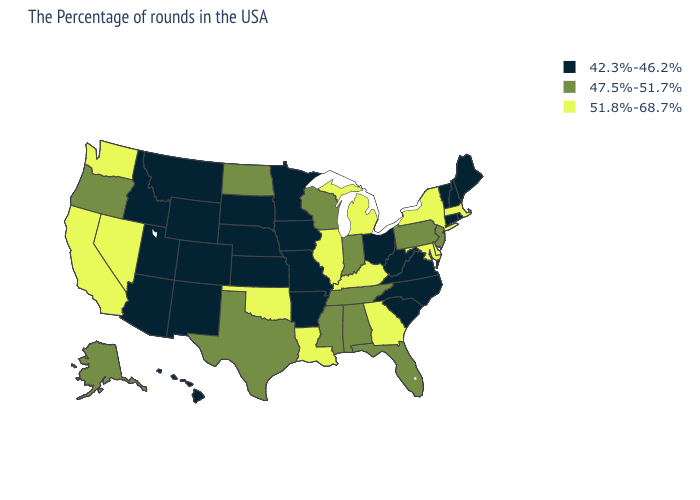Name the states that have a value in the range 47.5%-51.7%?
Keep it brief. New Jersey, Pennsylvania, Florida, Indiana, Alabama, Tennessee, Wisconsin, Mississippi, Texas, North Dakota, Oregon, Alaska. Does the map have missing data?
Keep it brief. No. Is the legend a continuous bar?
Quick response, please. No. Does Maryland have the same value as Washington?
Be succinct. Yes. Is the legend a continuous bar?
Quick response, please. No. What is the value of Delaware?
Quick response, please. 51.8%-68.7%. Name the states that have a value in the range 47.5%-51.7%?
Concise answer only. New Jersey, Pennsylvania, Florida, Indiana, Alabama, Tennessee, Wisconsin, Mississippi, Texas, North Dakota, Oregon, Alaska. Which states have the highest value in the USA?
Quick response, please. Massachusetts, New York, Delaware, Maryland, Georgia, Michigan, Kentucky, Illinois, Louisiana, Oklahoma, Nevada, California, Washington. What is the highest value in the Northeast ?
Give a very brief answer. 51.8%-68.7%. What is the value of South Carolina?
Quick response, please. 42.3%-46.2%. Is the legend a continuous bar?
Be succinct. No. Name the states that have a value in the range 47.5%-51.7%?
Keep it brief. New Jersey, Pennsylvania, Florida, Indiana, Alabama, Tennessee, Wisconsin, Mississippi, Texas, North Dakota, Oregon, Alaska. What is the highest value in the Northeast ?
Short answer required. 51.8%-68.7%. Among the states that border Illinois , does Missouri have the lowest value?
Write a very short answer. Yes. Name the states that have a value in the range 51.8%-68.7%?
Be succinct. Massachusetts, New York, Delaware, Maryland, Georgia, Michigan, Kentucky, Illinois, Louisiana, Oklahoma, Nevada, California, Washington. 